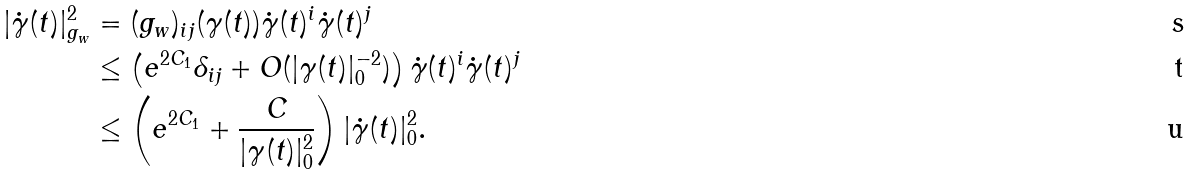Convert formula to latex. <formula><loc_0><loc_0><loc_500><loc_500>| \dot { \gamma } ( t ) | ^ { 2 } _ { g _ { w } } & = ( g _ { w } ) _ { i j } ( \gamma ( t ) ) \dot { \gamma } ( t ) ^ { i } \dot { \gamma } ( t ) ^ { j } \\ & \leq \left ( e ^ { 2 C _ { 1 } } \delta _ { i j } + O ( | \gamma ( t ) | _ { 0 } ^ { - 2 } ) \right ) \dot { \gamma } ( t ) ^ { i } \dot { \gamma } ( t ) ^ { j } \\ & \leq \left ( e ^ { 2 C _ { 1 } } + \frac { C } { | \gamma ( t ) | _ { 0 } ^ { 2 } } \right ) | \dot { \gamma } ( t ) | ^ { 2 } _ { 0 } .</formula> 